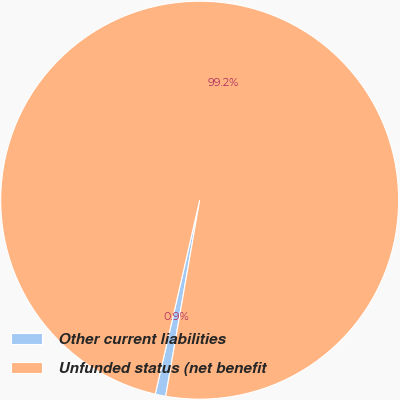<chart> <loc_0><loc_0><loc_500><loc_500><pie_chart><fcel>Other current liabilities<fcel>Unfunded status (net benefit<nl><fcel>0.85%<fcel>99.15%<nl></chart> 